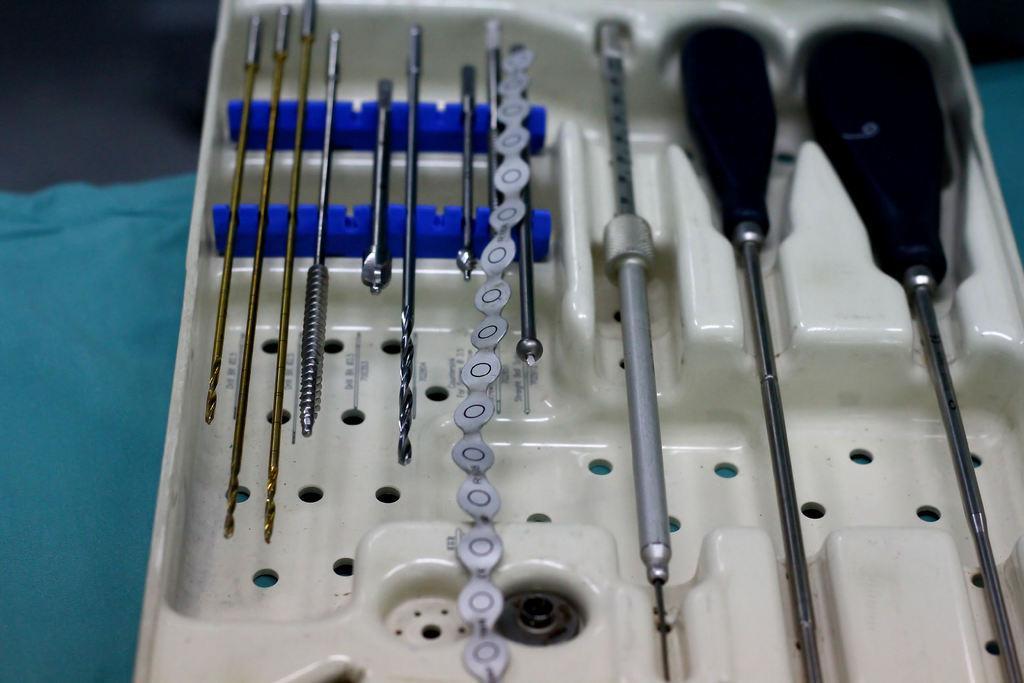Describe this image in one or two sentences. In this image there is a box, in that box there is are tools, under the box there is a cloth. 